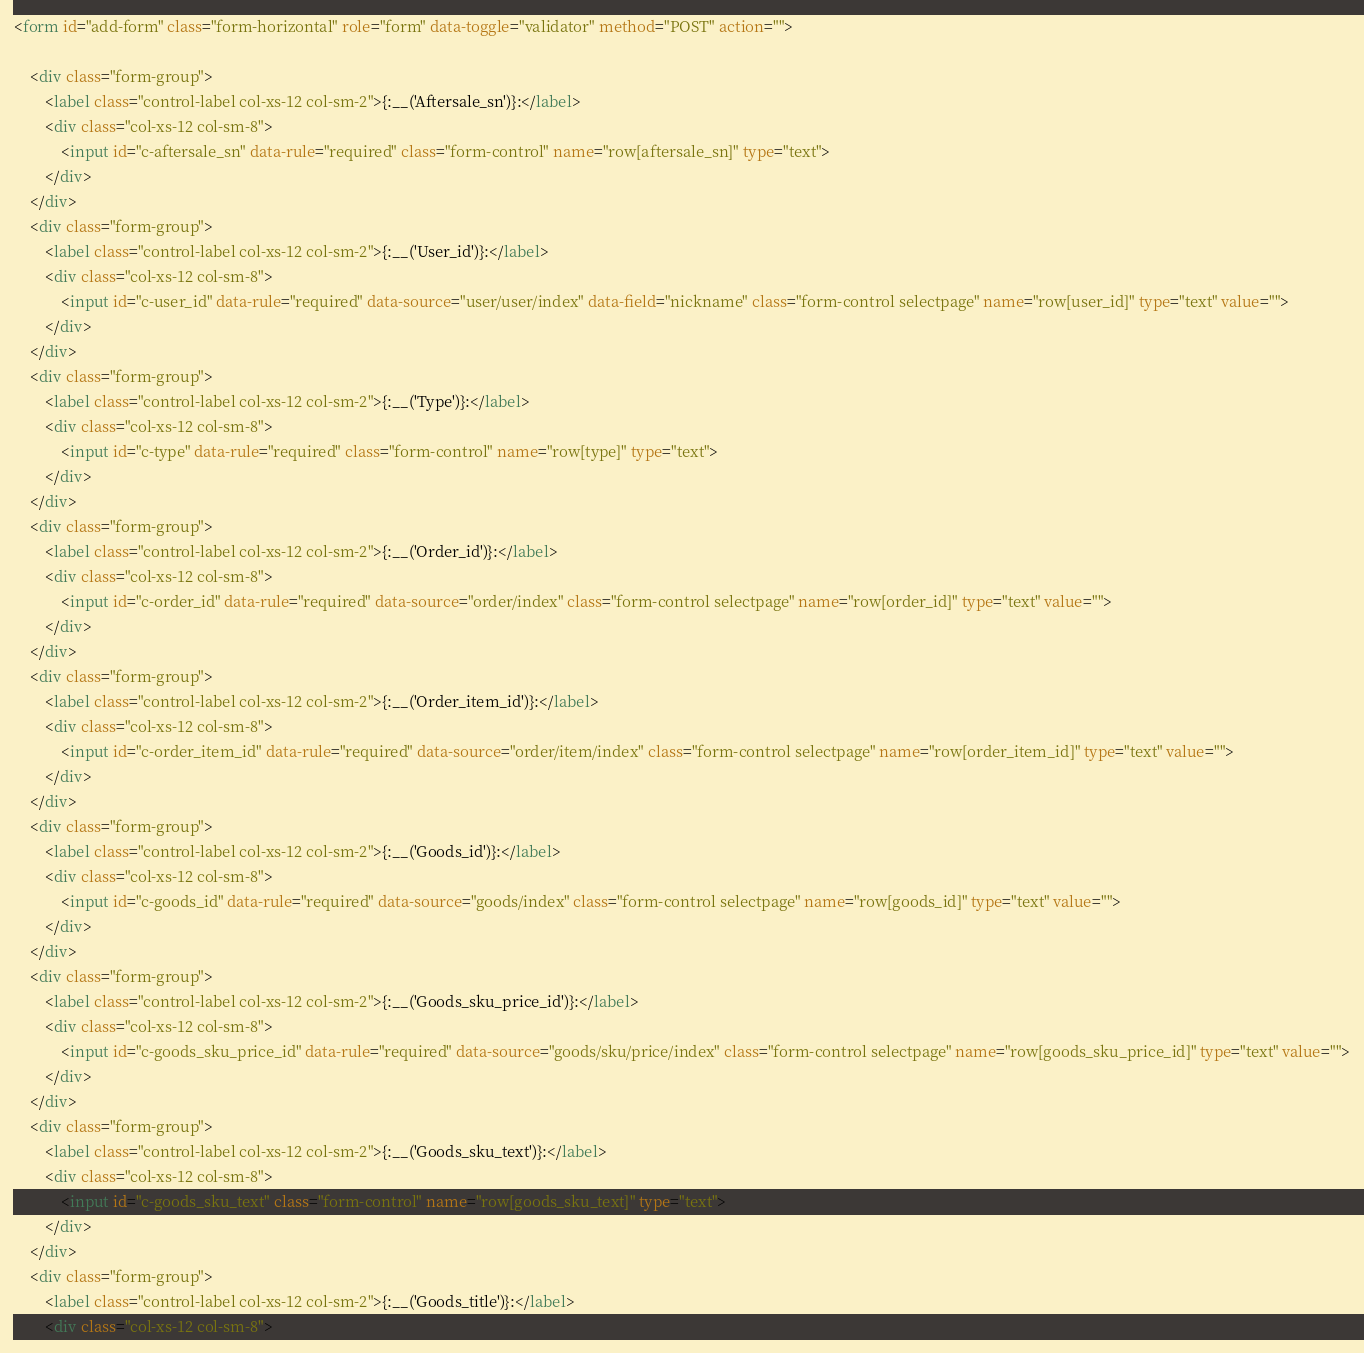<code> <loc_0><loc_0><loc_500><loc_500><_HTML_><form id="add-form" class="form-horizontal" role="form" data-toggle="validator" method="POST" action="">

    <div class="form-group">
        <label class="control-label col-xs-12 col-sm-2">{:__('Aftersale_sn')}:</label>
        <div class="col-xs-12 col-sm-8">
            <input id="c-aftersale_sn" data-rule="required" class="form-control" name="row[aftersale_sn]" type="text">
        </div>
    </div>
    <div class="form-group">
        <label class="control-label col-xs-12 col-sm-2">{:__('User_id')}:</label>
        <div class="col-xs-12 col-sm-8">
            <input id="c-user_id" data-rule="required" data-source="user/user/index" data-field="nickname" class="form-control selectpage" name="row[user_id]" type="text" value="">
        </div>
    </div>
    <div class="form-group">
        <label class="control-label col-xs-12 col-sm-2">{:__('Type')}:</label>
        <div class="col-xs-12 col-sm-8">
            <input id="c-type" data-rule="required" class="form-control" name="row[type]" type="text">
        </div>
    </div>
    <div class="form-group">
        <label class="control-label col-xs-12 col-sm-2">{:__('Order_id')}:</label>
        <div class="col-xs-12 col-sm-8">
            <input id="c-order_id" data-rule="required" data-source="order/index" class="form-control selectpage" name="row[order_id]" type="text" value="">
        </div>
    </div>
    <div class="form-group">
        <label class="control-label col-xs-12 col-sm-2">{:__('Order_item_id')}:</label>
        <div class="col-xs-12 col-sm-8">
            <input id="c-order_item_id" data-rule="required" data-source="order/item/index" class="form-control selectpage" name="row[order_item_id]" type="text" value="">
        </div>
    </div>
    <div class="form-group">
        <label class="control-label col-xs-12 col-sm-2">{:__('Goods_id')}:</label>
        <div class="col-xs-12 col-sm-8">
            <input id="c-goods_id" data-rule="required" data-source="goods/index" class="form-control selectpage" name="row[goods_id]" type="text" value="">
        </div>
    </div>
    <div class="form-group">
        <label class="control-label col-xs-12 col-sm-2">{:__('Goods_sku_price_id')}:</label>
        <div class="col-xs-12 col-sm-8">
            <input id="c-goods_sku_price_id" data-rule="required" data-source="goods/sku/price/index" class="form-control selectpage" name="row[goods_sku_price_id]" type="text" value="">
        </div>
    </div>
    <div class="form-group">
        <label class="control-label col-xs-12 col-sm-2">{:__('Goods_sku_text')}:</label>
        <div class="col-xs-12 col-sm-8">
            <input id="c-goods_sku_text" class="form-control" name="row[goods_sku_text]" type="text">
        </div>
    </div>
    <div class="form-group">
        <label class="control-label col-xs-12 col-sm-2">{:__('Goods_title')}:</label>
        <div class="col-xs-12 col-sm-8"></code> 